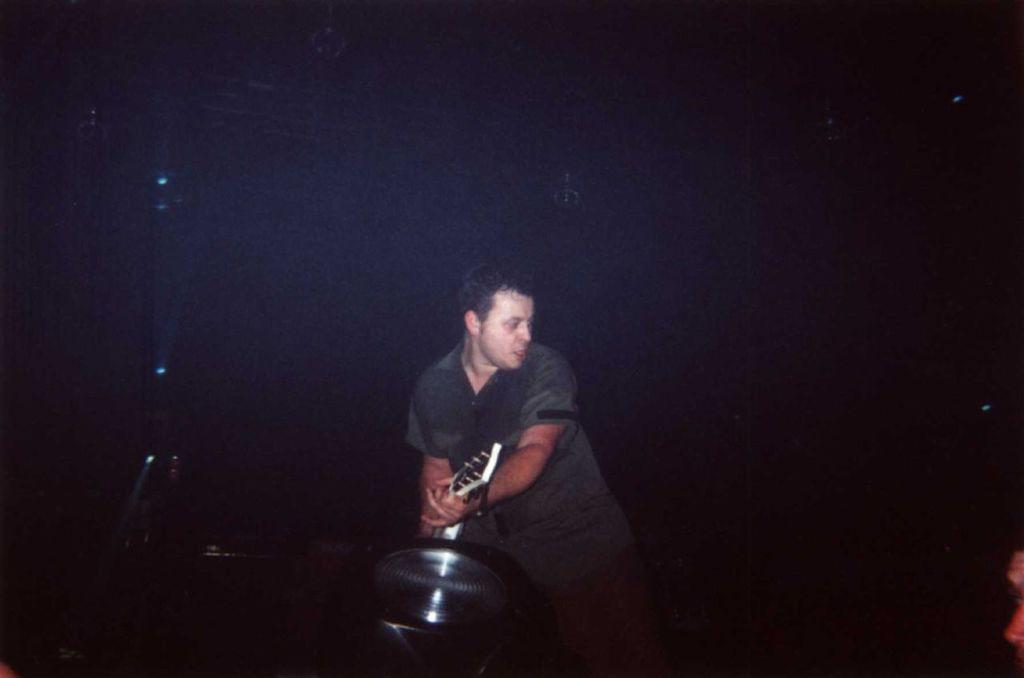What is the man in the image doing? The man is playing a guitar in the image. What other musical instrument can be seen in the image? There is a musical instrument at the bottom of the image. What can be seen in the background of the image? Lights are visible in the background of the image. Who else is visible in the image? A person's face is visible on the right at the bottom of the image. What type of cracker is being passed around in the image? There is no cracker present in the image. How many letters are visible on the musical instrument in the image? The image does not show any letters on the musical instrument. 